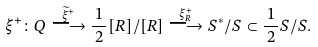<formula> <loc_0><loc_0><loc_500><loc_500>\xi ^ { + } \colon Q \stackrel { \widetilde { \xi } ^ { + } } { \longrightarrow } \frac { \, 1 \, } { 2 } [ R ] / [ R ] \stackrel { \xi ^ { + } _ { R } } { \longrightarrow } S ^ { \ast } / S \subset \frac { \, 1 \, } { 2 } S / S .</formula> 